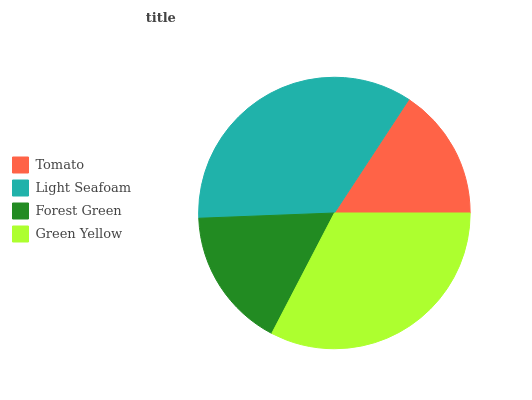Is Tomato the minimum?
Answer yes or no. Yes. Is Light Seafoam the maximum?
Answer yes or no. Yes. Is Forest Green the minimum?
Answer yes or no. No. Is Forest Green the maximum?
Answer yes or no. No. Is Light Seafoam greater than Forest Green?
Answer yes or no. Yes. Is Forest Green less than Light Seafoam?
Answer yes or no. Yes. Is Forest Green greater than Light Seafoam?
Answer yes or no. No. Is Light Seafoam less than Forest Green?
Answer yes or no. No. Is Green Yellow the high median?
Answer yes or no. Yes. Is Forest Green the low median?
Answer yes or no. Yes. Is Light Seafoam the high median?
Answer yes or no. No. Is Green Yellow the low median?
Answer yes or no. No. 